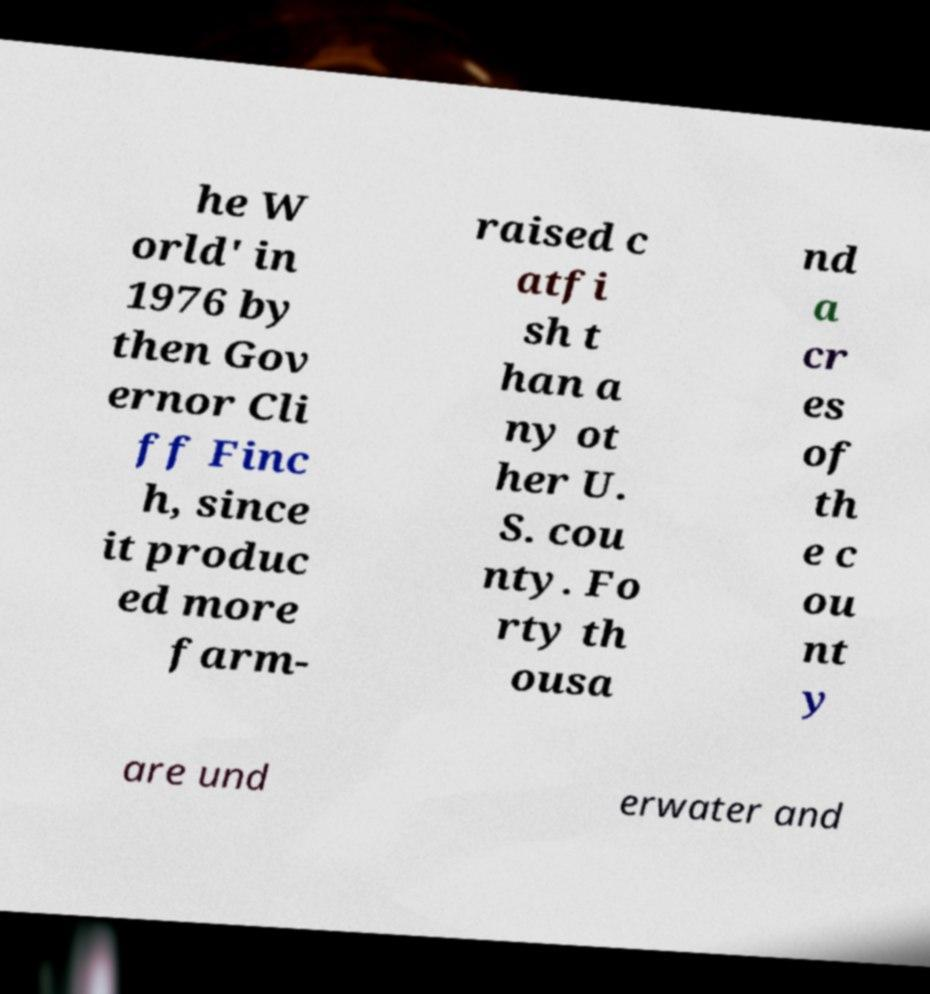Can you read and provide the text displayed in the image?This photo seems to have some interesting text. Can you extract and type it out for me? he W orld' in 1976 by then Gov ernor Cli ff Finc h, since it produc ed more farm- raised c atfi sh t han a ny ot her U. S. cou nty. Fo rty th ousa nd a cr es of th e c ou nt y are und erwater and 